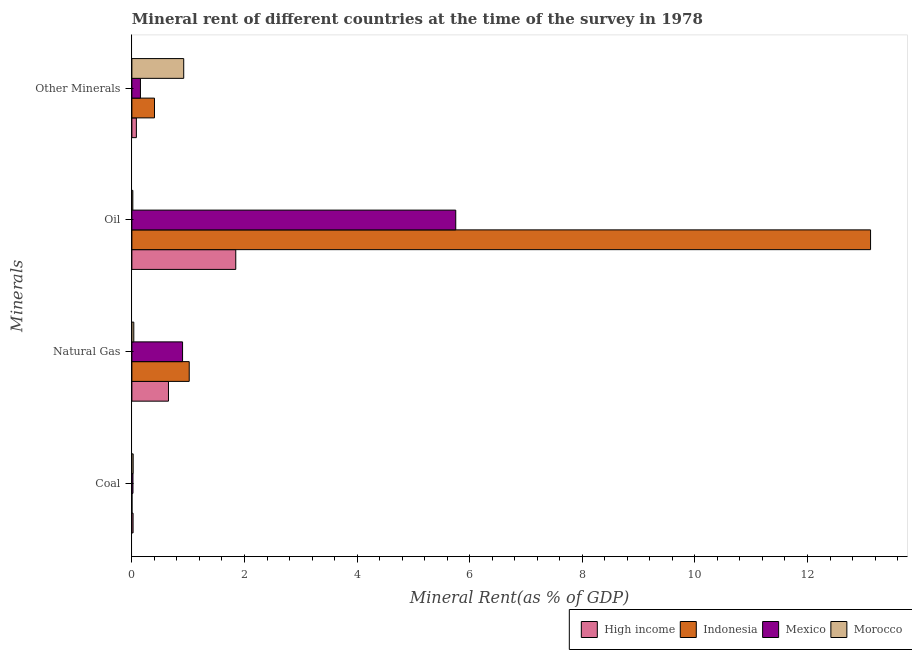How many different coloured bars are there?
Your answer should be very brief. 4. How many groups of bars are there?
Your answer should be compact. 4. Are the number of bars per tick equal to the number of legend labels?
Provide a succinct answer. Yes. Are the number of bars on each tick of the Y-axis equal?
Offer a very short reply. Yes. What is the label of the 1st group of bars from the top?
Offer a very short reply. Other Minerals. What is the coal rent in Mexico?
Provide a succinct answer. 0.02. Across all countries, what is the maximum  rent of other minerals?
Your answer should be very brief. 0.92. Across all countries, what is the minimum oil rent?
Make the answer very short. 0.02. In which country was the natural gas rent minimum?
Your answer should be very brief. Morocco. What is the total natural gas rent in the graph?
Provide a short and direct response. 2.6. What is the difference between the natural gas rent in Mexico and that in High income?
Your answer should be very brief. 0.25. What is the difference between the  rent of other minerals in Mexico and the natural gas rent in High income?
Ensure brevity in your answer.  -0.5. What is the average coal rent per country?
Your answer should be very brief. 0.02. What is the difference between the natural gas rent and  rent of other minerals in High income?
Your response must be concise. 0.57. In how many countries, is the coal rent greater than 11.6 %?
Provide a succinct answer. 0. What is the ratio of the oil rent in Indonesia to that in Mexico?
Your answer should be compact. 2.28. Is the  rent of other minerals in Morocco less than that in Indonesia?
Provide a short and direct response. No. What is the difference between the highest and the second highest natural gas rent?
Give a very brief answer. 0.12. What is the difference between the highest and the lowest oil rent?
Keep it short and to the point. 13.1. In how many countries, is the natural gas rent greater than the average natural gas rent taken over all countries?
Your answer should be compact. 2. Is it the case that in every country, the sum of the oil rent and  rent of other minerals is greater than the sum of coal rent and natural gas rent?
Offer a very short reply. No. What does the 2nd bar from the top in Natural Gas represents?
Provide a succinct answer. Mexico. Is it the case that in every country, the sum of the coal rent and natural gas rent is greater than the oil rent?
Your response must be concise. No. Are all the bars in the graph horizontal?
Ensure brevity in your answer.  Yes. How many countries are there in the graph?
Provide a succinct answer. 4. Does the graph contain grids?
Offer a terse response. No. Where does the legend appear in the graph?
Make the answer very short. Bottom right. How many legend labels are there?
Give a very brief answer. 4. How are the legend labels stacked?
Your response must be concise. Horizontal. What is the title of the graph?
Make the answer very short. Mineral rent of different countries at the time of the survey in 1978. Does "Syrian Arab Republic" appear as one of the legend labels in the graph?
Your answer should be very brief. No. What is the label or title of the X-axis?
Make the answer very short. Mineral Rent(as % of GDP). What is the label or title of the Y-axis?
Offer a very short reply. Minerals. What is the Mineral Rent(as % of GDP) of High income in Coal?
Provide a short and direct response. 0.02. What is the Mineral Rent(as % of GDP) of Indonesia in Coal?
Provide a short and direct response. 0. What is the Mineral Rent(as % of GDP) in Mexico in Coal?
Provide a short and direct response. 0.02. What is the Mineral Rent(as % of GDP) of Morocco in Coal?
Provide a short and direct response. 0.02. What is the Mineral Rent(as % of GDP) of High income in Natural Gas?
Offer a very short reply. 0.65. What is the Mineral Rent(as % of GDP) in Indonesia in Natural Gas?
Make the answer very short. 1.02. What is the Mineral Rent(as % of GDP) of Mexico in Natural Gas?
Offer a terse response. 0.9. What is the Mineral Rent(as % of GDP) in Morocco in Natural Gas?
Your answer should be very brief. 0.03. What is the Mineral Rent(as % of GDP) in High income in Oil?
Your response must be concise. 1.85. What is the Mineral Rent(as % of GDP) in Indonesia in Oil?
Provide a succinct answer. 13.12. What is the Mineral Rent(as % of GDP) of Mexico in Oil?
Provide a succinct answer. 5.75. What is the Mineral Rent(as % of GDP) of Morocco in Oil?
Give a very brief answer. 0.02. What is the Mineral Rent(as % of GDP) in High income in Other Minerals?
Provide a succinct answer. 0.08. What is the Mineral Rent(as % of GDP) of Indonesia in Other Minerals?
Your answer should be very brief. 0.4. What is the Mineral Rent(as % of GDP) in Mexico in Other Minerals?
Keep it short and to the point. 0.15. What is the Mineral Rent(as % of GDP) of Morocco in Other Minerals?
Provide a succinct answer. 0.92. Across all Minerals, what is the maximum Mineral Rent(as % of GDP) of High income?
Your response must be concise. 1.85. Across all Minerals, what is the maximum Mineral Rent(as % of GDP) in Indonesia?
Keep it short and to the point. 13.12. Across all Minerals, what is the maximum Mineral Rent(as % of GDP) of Mexico?
Give a very brief answer. 5.75. Across all Minerals, what is the maximum Mineral Rent(as % of GDP) in Morocco?
Provide a succinct answer. 0.92. Across all Minerals, what is the minimum Mineral Rent(as % of GDP) in High income?
Your answer should be very brief. 0.02. Across all Minerals, what is the minimum Mineral Rent(as % of GDP) of Indonesia?
Provide a short and direct response. 0. Across all Minerals, what is the minimum Mineral Rent(as % of GDP) of Mexico?
Provide a succinct answer. 0.02. Across all Minerals, what is the minimum Mineral Rent(as % of GDP) in Morocco?
Give a very brief answer. 0.02. What is the total Mineral Rent(as % of GDP) in High income in the graph?
Offer a terse response. 2.6. What is the total Mineral Rent(as % of GDP) of Indonesia in the graph?
Offer a very short reply. 14.54. What is the total Mineral Rent(as % of GDP) in Mexico in the graph?
Provide a succinct answer. 6.82. What is the total Mineral Rent(as % of GDP) of Morocco in the graph?
Keep it short and to the point. 1. What is the difference between the Mineral Rent(as % of GDP) of High income in Coal and that in Natural Gas?
Your answer should be very brief. -0.63. What is the difference between the Mineral Rent(as % of GDP) of Indonesia in Coal and that in Natural Gas?
Make the answer very short. -1.02. What is the difference between the Mineral Rent(as % of GDP) in Mexico in Coal and that in Natural Gas?
Offer a terse response. -0.88. What is the difference between the Mineral Rent(as % of GDP) in Morocco in Coal and that in Natural Gas?
Ensure brevity in your answer.  -0.01. What is the difference between the Mineral Rent(as % of GDP) in High income in Coal and that in Oil?
Provide a short and direct response. -1.82. What is the difference between the Mineral Rent(as % of GDP) of Indonesia in Coal and that in Oil?
Make the answer very short. -13.12. What is the difference between the Mineral Rent(as % of GDP) in Mexico in Coal and that in Oil?
Provide a succinct answer. -5.73. What is the difference between the Mineral Rent(as % of GDP) of Morocco in Coal and that in Oil?
Your answer should be compact. 0.01. What is the difference between the Mineral Rent(as % of GDP) of High income in Coal and that in Other Minerals?
Offer a terse response. -0.06. What is the difference between the Mineral Rent(as % of GDP) in Indonesia in Coal and that in Other Minerals?
Offer a very short reply. -0.4. What is the difference between the Mineral Rent(as % of GDP) in Mexico in Coal and that in Other Minerals?
Give a very brief answer. -0.13. What is the difference between the Mineral Rent(as % of GDP) in Morocco in Coal and that in Other Minerals?
Give a very brief answer. -0.9. What is the difference between the Mineral Rent(as % of GDP) in High income in Natural Gas and that in Oil?
Ensure brevity in your answer.  -1.2. What is the difference between the Mineral Rent(as % of GDP) of Indonesia in Natural Gas and that in Oil?
Offer a very short reply. -12.1. What is the difference between the Mineral Rent(as % of GDP) of Mexico in Natural Gas and that in Oil?
Provide a short and direct response. -4.85. What is the difference between the Mineral Rent(as % of GDP) in Morocco in Natural Gas and that in Oil?
Your answer should be compact. 0.02. What is the difference between the Mineral Rent(as % of GDP) in High income in Natural Gas and that in Other Minerals?
Your response must be concise. 0.57. What is the difference between the Mineral Rent(as % of GDP) in Indonesia in Natural Gas and that in Other Minerals?
Your answer should be very brief. 0.62. What is the difference between the Mineral Rent(as % of GDP) of Mexico in Natural Gas and that in Other Minerals?
Keep it short and to the point. 0.75. What is the difference between the Mineral Rent(as % of GDP) of Morocco in Natural Gas and that in Other Minerals?
Provide a short and direct response. -0.89. What is the difference between the Mineral Rent(as % of GDP) in High income in Oil and that in Other Minerals?
Your answer should be compact. 1.77. What is the difference between the Mineral Rent(as % of GDP) in Indonesia in Oil and that in Other Minerals?
Ensure brevity in your answer.  12.72. What is the difference between the Mineral Rent(as % of GDP) in Mexico in Oil and that in Other Minerals?
Keep it short and to the point. 5.6. What is the difference between the Mineral Rent(as % of GDP) in Morocco in Oil and that in Other Minerals?
Your answer should be very brief. -0.9. What is the difference between the Mineral Rent(as % of GDP) in High income in Coal and the Mineral Rent(as % of GDP) in Indonesia in Natural Gas?
Give a very brief answer. -1. What is the difference between the Mineral Rent(as % of GDP) in High income in Coal and the Mineral Rent(as % of GDP) in Mexico in Natural Gas?
Make the answer very short. -0.88. What is the difference between the Mineral Rent(as % of GDP) of High income in Coal and the Mineral Rent(as % of GDP) of Morocco in Natural Gas?
Offer a very short reply. -0.01. What is the difference between the Mineral Rent(as % of GDP) of Indonesia in Coal and the Mineral Rent(as % of GDP) of Mexico in Natural Gas?
Your response must be concise. -0.9. What is the difference between the Mineral Rent(as % of GDP) of Indonesia in Coal and the Mineral Rent(as % of GDP) of Morocco in Natural Gas?
Provide a short and direct response. -0.03. What is the difference between the Mineral Rent(as % of GDP) in Mexico in Coal and the Mineral Rent(as % of GDP) in Morocco in Natural Gas?
Keep it short and to the point. -0.01. What is the difference between the Mineral Rent(as % of GDP) of High income in Coal and the Mineral Rent(as % of GDP) of Indonesia in Oil?
Your answer should be very brief. -13.1. What is the difference between the Mineral Rent(as % of GDP) in High income in Coal and the Mineral Rent(as % of GDP) in Mexico in Oil?
Offer a terse response. -5.73. What is the difference between the Mineral Rent(as % of GDP) in High income in Coal and the Mineral Rent(as % of GDP) in Morocco in Oil?
Your answer should be very brief. 0. What is the difference between the Mineral Rent(as % of GDP) of Indonesia in Coal and the Mineral Rent(as % of GDP) of Mexico in Oil?
Give a very brief answer. -5.75. What is the difference between the Mineral Rent(as % of GDP) in Indonesia in Coal and the Mineral Rent(as % of GDP) in Morocco in Oil?
Provide a short and direct response. -0.02. What is the difference between the Mineral Rent(as % of GDP) of Mexico in Coal and the Mineral Rent(as % of GDP) of Morocco in Oil?
Your answer should be compact. 0. What is the difference between the Mineral Rent(as % of GDP) of High income in Coal and the Mineral Rent(as % of GDP) of Indonesia in Other Minerals?
Your response must be concise. -0.38. What is the difference between the Mineral Rent(as % of GDP) in High income in Coal and the Mineral Rent(as % of GDP) in Mexico in Other Minerals?
Make the answer very short. -0.13. What is the difference between the Mineral Rent(as % of GDP) in High income in Coal and the Mineral Rent(as % of GDP) in Morocco in Other Minerals?
Your answer should be very brief. -0.9. What is the difference between the Mineral Rent(as % of GDP) in Indonesia in Coal and the Mineral Rent(as % of GDP) in Mexico in Other Minerals?
Keep it short and to the point. -0.15. What is the difference between the Mineral Rent(as % of GDP) in Indonesia in Coal and the Mineral Rent(as % of GDP) in Morocco in Other Minerals?
Make the answer very short. -0.92. What is the difference between the Mineral Rent(as % of GDP) of Mexico in Coal and the Mineral Rent(as % of GDP) of Morocco in Other Minerals?
Your answer should be very brief. -0.9. What is the difference between the Mineral Rent(as % of GDP) in High income in Natural Gas and the Mineral Rent(as % of GDP) in Indonesia in Oil?
Provide a short and direct response. -12.47. What is the difference between the Mineral Rent(as % of GDP) of High income in Natural Gas and the Mineral Rent(as % of GDP) of Mexico in Oil?
Provide a short and direct response. -5.1. What is the difference between the Mineral Rent(as % of GDP) in High income in Natural Gas and the Mineral Rent(as % of GDP) in Morocco in Oil?
Your answer should be compact. 0.63. What is the difference between the Mineral Rent(as % of GDP) of Indonesia in Natural Gas and the Mineral Rent(as % of GDP) of Mexico in Oil?
Provide a short and direct response. -4.73. What is the difference between the Mineral Rent(as % of GDP) in Mexico in Natural Gas and the Mineral Rent(as % of GDP) in Morocco in Oil?
Make the answer very short. 0.88. What is the difference between the Mineral Rent(as % of GDP) of High income in Natural Gas and the Mineral Rent(as % of GDP) of Indonesia in Other Minerals?
Offer a very short reply. 0.25. What is the difference between the Mineral Rent(as % of GDP) of High income in Natural Gas and the Mineral Rent(as % of GDP) of Mexico in Other Minerals?
Provide a succinct answer. 0.5. What is the difference between the Mineral Rent(as % of GDP) of High income in Natural Gas and the Mineral Rent(as % of GDP) of Morocco in Other Minerals?
Ensure brevity in your answer.  -0.27. What is the difference between the Mineral Rent(as % of GDP) of Indonesia in Natural Gas and the Mineral Rent(as % of GDP) of Mexico in Other Minerals?
Your answer should be very brief. 0.87. What is the difference between the Mineral Rent(as % of GDP) in Indonesia in Natural Gas and the Mineral Rent(as % of GDP) in Morocco in Other Minerals?
Your response must be concise. 0.1. What is the difference between the Mineral Rent(as % of GDP) of Mexico in Natural Gas and the Mineral Rent(as % of GDP) of Morocco in Other Minerals?
Give a very brief answer. -0.02. What is the difference between the Mineral Rent(as % of GDP) in High income in Oil and the Mineral Rent(as % of GDP) in Indonesia in Other Minerals?
Your answer should be compact. 1.44. What is the difference between the Mineral Rent(as % of GDP) in High income in Oil and the Mineral Rent(as % of GDP) in Mexico in Other Minerals?
Ensure brevity in your answer.  1.69. What is the difference between the Mineral Rent(as % of GDP) of High income in Oil and the Mineral Rent(as % of GDP) of Morocco in Other Minerals?
Ensure brevity in your answer.  0.92. What is the difference between the Mineral Rent(as % of GDP) of Indonesia in Oil and the Mineral Rent(as % of GDP) of Mexico in Other Minerals?
Your answer should be compact. 12.97. What is the difference between the Mineral Rent(as % of GDP) of Indonesia in Oil and the Mineral Rent(as % of GDP) of Morocco in Other Minerals?
Give a very brief answer. 12.2. What is the difference between the Mineral Rent(as % of GDP) in Mexico in Oil and the Mineral Rent(as % of GDP) in Morocco in Other Minerals?
Your response must be concise. 4.83. What is the average Mineral Rent(as % of GDP) in High income per Minerals?
Keep it short and to the point. 0.65. What is the average Mineral Rent(as % of GDP) of Indonesia per Minerals?
Your response must be concise. 3.64. What is the average Mineral Rent(as % of GDP) of Mexico per Minerals?
Offer a terse response. 1.71. What is the average Mineral Rent(as % of GDP) of Morocco per Minerals?
Provide a succinct answer. 0.25. What is the difference between the Mineral Rent(as % of GDP) of High income and Mineral Rent(as % of GDP) of Indonesia in Coal?
Ensure brevity in your answer.  0.02. What is the difference between the Mineral Rent(as % of GDP) of High income and Mineral Rent(as % of GDP) of Mexico in Coal?
Your answer should be very brief. 0. What is the difference between the Mineral Rent(as % of GDP) in High income and Mineral Rent(as % of GDP) in Morocco in Coal?
Provide a succinct answer. -0. What is the difference between the Mineral Rent(as % of GDP) of Indonesia and Mineral Rent(as % of GDP) of Mexico in Coal?
Your answer should be compact. -0.02. What is the difference between the Mineral Rent(as % of GDP) of Indonesia and Mineral Rent(as % of GDP) of Morocco in Coal?
Provide a short and direct response. -0.02. What is the difference between the Mineral Rent(as % of GDP) of Mexico and Mineral Rent(as % of GDP) of Morocco in Coal?
Keep it short and to the point. -0. What is the difference between the Mineral Rent(as % of GDP) of High income and Mineral Rent(as % of GDP) of Indonesia in Natural Gas?
Provide a short and direct response. -0.37. What is the difference between the Mineral Rent(as % of GDP) of High income and Mineral Rent(as % of GDP) of Mexico in Natural Gas?
Offer a very short reply. -0.25. What is the difference between the Mineral Rent(as % of GDP) of High income and Mineral Rent(as % of GDP) of Morocco in Natural Gas?
Your answer should be very brief. 0.62. What is the difference between the Mineral Rent(as % of GDP) in Indonesia and Mineral Rent(as % of GDP) in Mexico in Natural Gas?
Give a very brief answer. 0.12. What is the difference between the Mineral Rent(as % of GDP) in Indonesia and Mineral Rent(as % of GDP) in Morocco in Natural Gas?
Provide a succinct answer. 0.98. What is the difference between the Mineral Rent(as % of GDP) of Mexico and Mineral Rent(as % of GDP) of Morocco in Natural Gas?
Keep it short and to the point. 0.87. What is the difference between the Mineral Rent(as % of GDP) in High income and Mineral Rent(as % of GDP) in Indonesia in Oil?
Your response must be concise. -11.27. What is the difference between the Mineral Rent(as % of GDP) of High income and Mineral Rent(as % of GDP) of Mexico in Oil?
Give a very brief answer. -3.91. What is the difference between the Mineral Rent(as % of GDP) in High income and Mineral Rent(as % of GDP) in Morocco in Oil?
Offer a terse response. 1.83. What is the difference between the Mineral Rent(as % of GDP) of Indonesia and Mineral Rent(as % of GDP) of Mexico in Oil?
Your response must be concise. 7.37. What is the difference between the Mineral Rent(as % of GDP) in Indonesia and Mineral Rent(as % of GDP) in Morocco in Oil?
Your response must be concise. 13.1. What is the difference between the Mineral Rent(as % of GDP) of Mexico and Mineral Rent(as % of GDP) of Morocco in Oil?
Make the answer very short. 5.74. What is the difference between the Mineral Rent(as % of GDP) in High income and Mineral Rent(as % of GDP) in Indonesia in Other Minerals?
Keep it short and to the point. -0.32. What is the difference between the Mineral Rent(as % of GDP) in High income and Mineral Rent(as % of GDP) in Mexico in Other Minerals?
Offer a very short reply. -0.07. What is the difference between the Mineral Rent(as % of GDP) of High income and Mineral Rent(as % of GDP) of Morocco in Other Minerals?
Offer a terse response. -0.84. What is the difference between the Mineral Rent(as % of GDP) of Indonesia and Mineral Rent(as % of GDP) of Mexico in Other Minerals?
Make the answer very short. 0.25. What is the difference between the Mineral Rent(as % of GDP) of Indonesia and Mineral Rent(as % of GDP) of Morocco in Other Minerals?
Your answer should be compact. -0.52. What is the difference between the Mineral Rent(as % of GDP) of Mexico and Mineral Rent(as % of GDP) of Morocco in Other Minerals?
Provide a succinct answer. -0.77. What is the ratio of the Mineral Rent(as % of GDP) of High income in Coal to that in Natural Gas?
Your answer should be compact. 0.03. What is the ratio of the Mineral Rent(as % of GDP) of Indonesia in Coal to that in Natural Gas?
Your response must be concise. 0. What is the ratio of the Mineral Rent(as % of GDP) in Mexico in Coal to that in Natural Gas?
Ensure brevity in your answer.  0.02. What is the ratio of the Mineral Rent(as % of GDP) in Morocco in Coal to that in Natural Gas?
Give a very brief answer. 0.68. What is the ratio of the Mineral Rent(as % of GDP) of High income in Coal to that in Oil?
Your answer should be very brief. 0.01. What is the ratio of the Mineral Rent(as % of GDP) of Indonesia in Coal to that in Oil?
Your answer should be compact. 0. What is the ratio of the Mineral Rent(as % of GDP) of Mexico in Coal to that in Oil?
Provide a succinct answer. 0. What is the ratio of the Mineral Rent(as % of GDP) of Morocco in Coal to that in Oil?
Give a very brief answer. 1.36. What is the ratio of the Mineral Rent(as % of GDP) in High income in Coal to that in Other Minerals?
Your answer should be compact. 0.27. What is the ratio of the Mineral Rent(as % of GDP) of Indonesia in Coal to that in Other Minerals?
Your response must be concise. 0. What is the ratio of the Mineral Rent(as % of GDP) of Mexico in Coal to that in Other Minerals?
Ensure brevity in your answer.  0.13. What is the ratio of the Mineral Rent(as % of GDP) in Morocco in Coal to that in Other Minerals?
Give a very brief answer. 0.03. What is the ratio of the Mineral Rent(as % of GDP) of High income in Natural Gas to that in Oil?
Provide a succinct answer. 0.35. What is the ratio of the Mineral Rent(as % of GDP) of Indonesia in Natural Gas to that in Oil?
Your response must be concise. 0.08. What is the ratio of the Mineral Rent(as % of GDP) of Mexico in Natural Gas to that in Oil?
Provide a short and direct response. 0.16. What is the ratio of the Mineral Rent(as % of GDP) in Morocco in Natural Gas to that in Oil?
Ensure brevity in your answer.  2. What is the ratio of the Mineral Rent(as % of GDP) in High income in Natural Gas to that in Other Minerals?
Give a very brief answer. 8.12. What is the ratio of the Mineral Rent(as % of GDP) in Indonesia in Natural Gas to that in Other Minerals?
Offer a very short reply. 2.54. What is the ratio of the Mineral Rent(as % of GDP) of Mexico in Natural Gas to that in Other Minerals?
Offer a very short reply. 5.92. What is the ratio of the Mineral Rent(as % of GDP) of Morocco in Natural Gas to that in Other Minerals?
Provide a short and direct response. 0.04. What is the ratio of the Mineral Rent(as % of GDP) of High income in Oil to that in Other Minerals?
Your answer should be compact. 23.06. What is the ratio of the Mineral Rent(as % of GDP) in Indonesia in Oil to that in Other Minerals?
Keep it short and to the point. 32.67. What is the ratio of the Mineral Rent(as % of GDP) in Mexico in Oil to that in Other Minerals?
Your response must be concise. 37.81. What is the ratio of the Mineral Rent(as % of GDP) of Morocco in Oil to that in Other Minerals?
Your answer should be compact. 0.02. What is the difference between the highest and the second highest Mineral Rent(as % of GDP) in High income?
Offer a very short reply. 1.2. What is the difference between the highest and the second highest Mineral Rent(as % of GDP) of Indonesia?
Offer a very short reply. 12.1. What is the difference between the highest and the second highest Mineral Rent(as % of GDP) of Mexico?
Ensure brevity in your answer.  4.85. What is the difference between the highest and the second highest Mineral Rent(as % of GDP) of Morocco?
Offer a terse response. 0.89. What is the difference between the highest and the lowest Mineral Rent(as % of GDP) in High income?
Your answer should be compact. 1.82. What is the difference between the highest and the lowest Mineral Rent(as % of GDP) of Indonesia?
Provide a succinct answer. 13.12. What is the difference between the highest and the lowest Mineral Rent(as % of GDP) in Mexico?
Keep it short and to the point. 5.73. What is the difference between the highest and the lowest Mineral Rent(as % of GDP) in Morocco?
Provide a succinct answer. 0.9. 